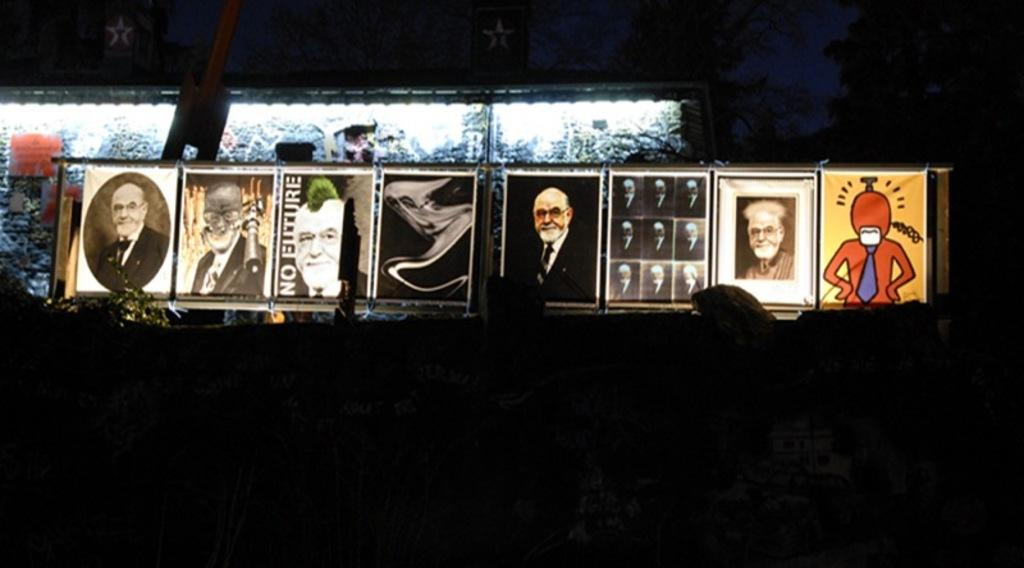What type of objects can be seen in the image? There are photo frames and a glass object in the image. Can you describe the background of the image? The background of the image is dark. What is the weight of the zephyr in the image? There is no zephyr present in the image, so it is not possible to determine its weight. 